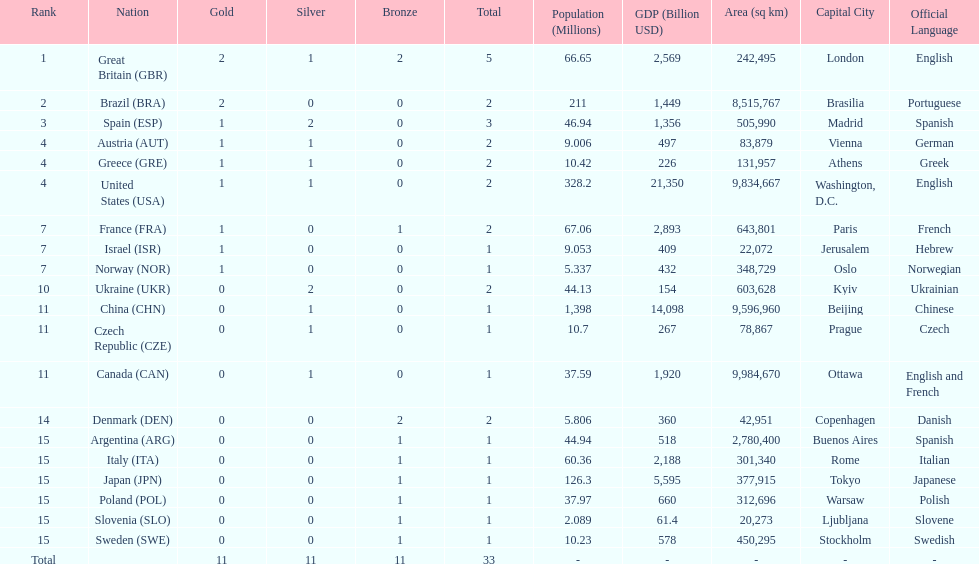What nation was next to great britain in total medal count? Spain. 